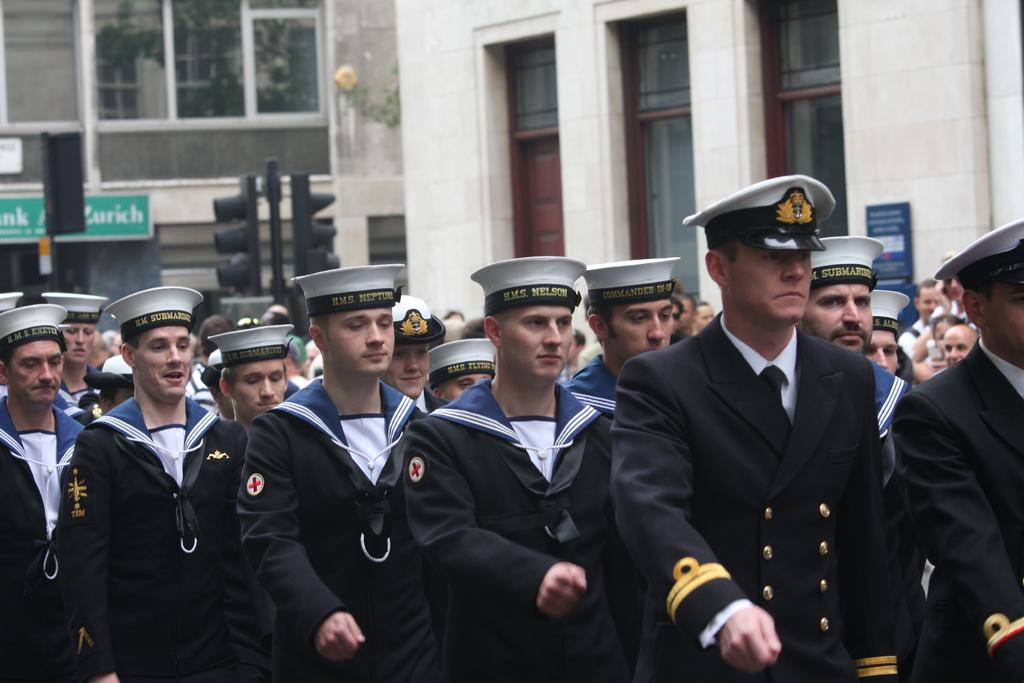What is the main subject of the image? The main subject of the image is people in the center. What are the people wearing? The people are wearing uniforms. What can be seen in the background of the image? There are buildings, windows, poles, and a poster visible in the background. How many children are holding a twig in the image? There are no children or twigs present in the image. What type of rock can be seen in the image? There is no rock present in the image. 